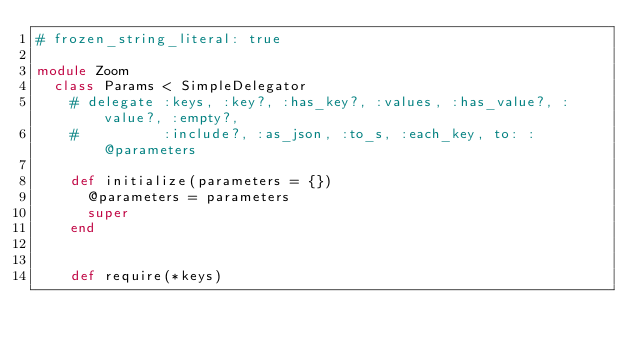Convert code to text. <code><loc_0><loc_0><loc_500><loc_500><_Ruby_># frozen_string_literal: true

module Zoom
  class Params < SimpleDelegator
    # delegate :keys, :key?, :has_key?, :values, :has_value?, :value?, :empty?,
    #          :include?, :as_json, :to_s, :each_key, to: :@parameters

    def initialize(parameters = {})
      @parameters = parameters
      super
    end


    def require(*keys)</code> 